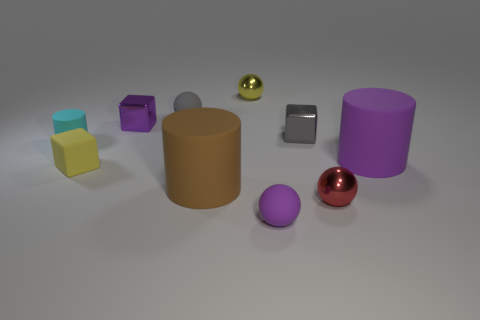Subtract all tiny shiny blocks. How many blocks are left? 1 Subtract all yellow cubes. How many cubes are left? 2 Subtract 2 cylinders. How many cylinders are left? 1 Subtract all tiny purple metal things. Subtract all cyan matte cylinders. How many objects are left? 8 Add 5 purple rubber objects. How many purple rubber objects are left? 7 Add 4 small purple things. How many small purple things exist? 6 Subtract 1 red spheres. How many objects are left? 9 Subtract all balls. How many objects are left? 6 Subtract all blue blocks. Subtract all green cylinders. How many blocks are left? 3 Subtract all green cylinders. How many yellow balls are left? 1 